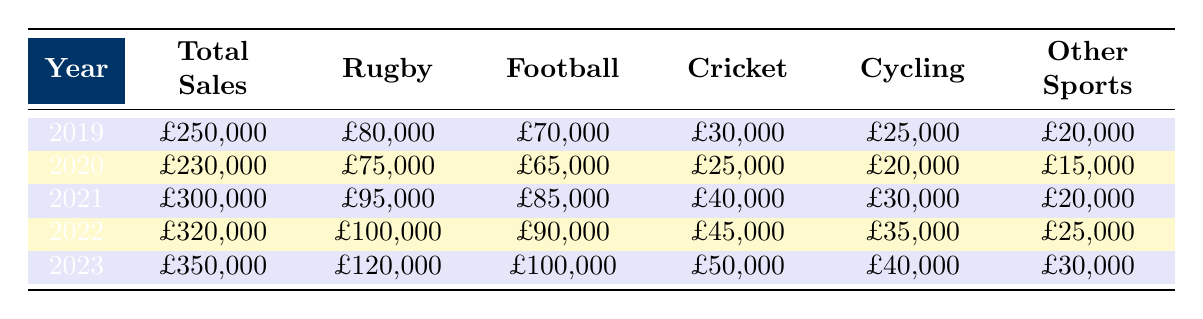What was the total sales in 2022? The table shows the total sales for each year. In 2022, the total sales are listed as £320,000.
Answer: £320,000 Which year had the highest sales of rugby merchandise? By checking the rugby merchandise column for each year, 2023 has the highest sales at £120,000.
Answer: £120,000 What is the total sales for football merchandise over the last five years? To find the total, sum up the football sales: £70,000 + £65,000 + £85,000 + £90,000 + £100,000 = £410,000.
Answer: £410,000 In which year did cricket merchandise sales exceed £40,000? Looking at the cricket merchandise row, sales were £30,000 in 2019, £25,000 in 2020, £40,000 in 2021, £45,000 in 2022, and £50,000 in 2023, meaning they exceeded £40,000 starting from 2021.
Answer: 2021 What percentage of total sales in 2021 came from cycling merchandise? In 2021, total sales were £300,000 and cycling merchandise sales were £30,000. To find the percentage, calculate (30,000 / 300,000) * 100 = 10%.
Answer: 10% Did total sales increase every year from 2019 to 2023? By examining the total sales for each year, they are: £250,000 (2019), £230,000 (2020), £300,000 (2021), £320,000 (2022), and £350,000 (2023). Since sales decreased from 2019 to 2020, the answer is no.
Answer: No What was the average sales for rugby merchandise from 2019 to 2023? The sales figures for rugby merchandise are £80,000, £75,000, £95,000, £100,000, and £120,000. To calculate the average, add them (80,000 + 75,000 + 95,000 + 100,000 + 120,000 = 470,000) and divide by 5: 470,000 / 5 = £94,000.
Answer: £94,000 In 2023, how much more was spent on rugby merchandise compared to cricket merchandise? The figures for 2023 show rugby merchandise sales at £120,000 and cricket merchandise at £50,000. Subtracting gives £120,000 - £50,000 = £70,000.
Answer: £70,000 What was the total sales in the year with the lowest football merchandise sales? From the football merchandise column, the sales are £70,000 (2019), £65,000 (2020), £85,000 (2021), £90,000 (2022), and £100,000 (2023). The lowest was in 2020, where total sales were £230,000.
Answer: £230,000 Which sport had the lowest total sales over the five-year period? Adding up the sales for each sport, rugby was £80,000 + £75,000 + £95,000 + £100,000 + £120,000 = £470,000, football was £70,000 + £65,000 + £85,000 + £90,000 + £100,000 = £410,000, cricket was £30,000 + £25,000 + £40,000 + £45,000 + £50,000 = £190,000, cycling was £25,000 + £20,000 + £30,000 + £35,000 + £40,000 = £150,000, and other sports was £20,000 + £15,000 + £20,000 + £25,000 + £30,000 = £110,000. The sport with the lowest sales is cycling at £150,000.
Answer: Cycling 